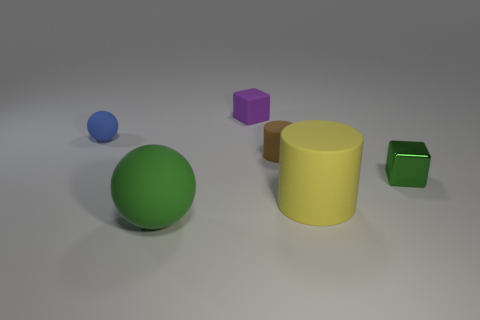Add 1 yellow cylinders. How many objects exist? 7 Subtract all cylinders. How many objects are left? 4 Add 4 rubber cubes. How many rubber cubes are left? 5 Add 1 tiny green shiny things. How many tiny green shiny things exist? 2 Subtract 0 cyan balls. How many objects are left? 6 Subtract all brown cylinders. Subtract all big gray metallic things. How many objects are left? 5 